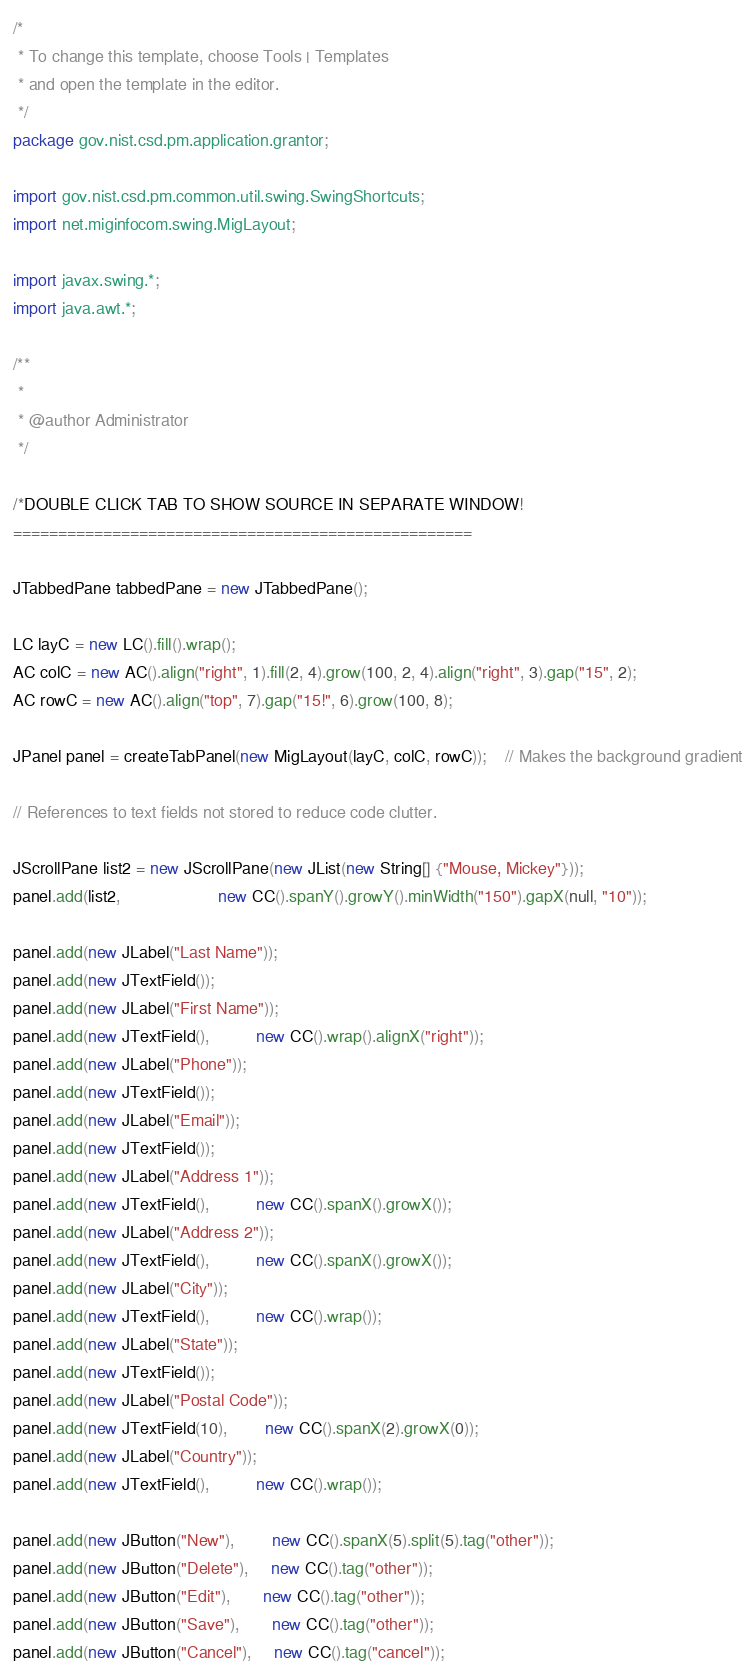<code> <loc_0><loc_0><loc_500><loc_500><_Java_>/*
 * To change this template, choose Tools | Templates
 * and open the template in the editor.
 */
package gov.nist.csd.pm.application.grantor;

import gov.nist.csd.pm.common.util.swing.SwingShortcuts;
import net.miginfocom.swing.MigLayout;

import javax.swing.*;
import java.awt.*;

/**
 *
 * @author Administrator
 */

/*DOUBLE CLICK TAB TO SHOW SOURCE IN SEPARATE WINDOW!
===================================================

JTabbedPane tabbedPane = new JTabbedPane();

LC layC = new LC().fill().wrap();
AC colC = new AC().align("right", 1).fill(2, 4).grow(100, 2, 4).align("right", 3).gap("15", 2);
AC rowC = new AC().align("top", 7).gap("15!", 6).grow(100, 8);

JPanel panel = createTabPanel(new MigLayout(layC, colC, rowC));    // Makes the background gradient

// References to text fields not stored to reduce code clutter.

JScrollPane list2 = new JScrollPane(new JList(new String[] {"Mouse, Mickey"}));
panel.add(list2,                     new CC().spanY().growY().minWidth("150").gapX(null, "10"));

panel.add(new JLabel("Last Name"));
panel.add(new JTextField());
panel.add(new JLabel("First Name"));
panel.add(new JTextField(),          new CC().wrap().alignX("right"));
panel.add(new JLabel("Phone"));
panel.add(new JTextField());
panel.add(new JLabel("Email"));
panel.add(new JTextField());
panel.add(new JLabel("Address 1"));
panel.add(new JTextField(),          new CC().spanX().growX());
panel.add(new JLabel("Address 2"));
panel.add(new JTextField(),          new CC().spanX().growX());
panel.add(new JLabel("City"));
panel.add(new JTextField(),          new CC().wrap());
panel.add(new JLabel("State"));
panel.add(new JTextField());
panel.add(new JLabel("Postal Code"));
panel.add(new JTextField(10),        new CC().spanX(2).growX(0));
panel.add(new JLabel("Country"));
panel.add(new JTextField(),          new CC().wrap());

panel.add(new JButton("New"),        new CC().spanX(5).split(5).tag("other"));
panel.add(new JButton("Delete"),     new CC().tag("other"));
panel.add(new JButton("Edit"),       new CC().tag("other"));
panel.add(new JButton("Save"),       new CC().tag("other"));
panel.add(new JButton("Cancel"),     new CC().tag("cancel"));
</code> 